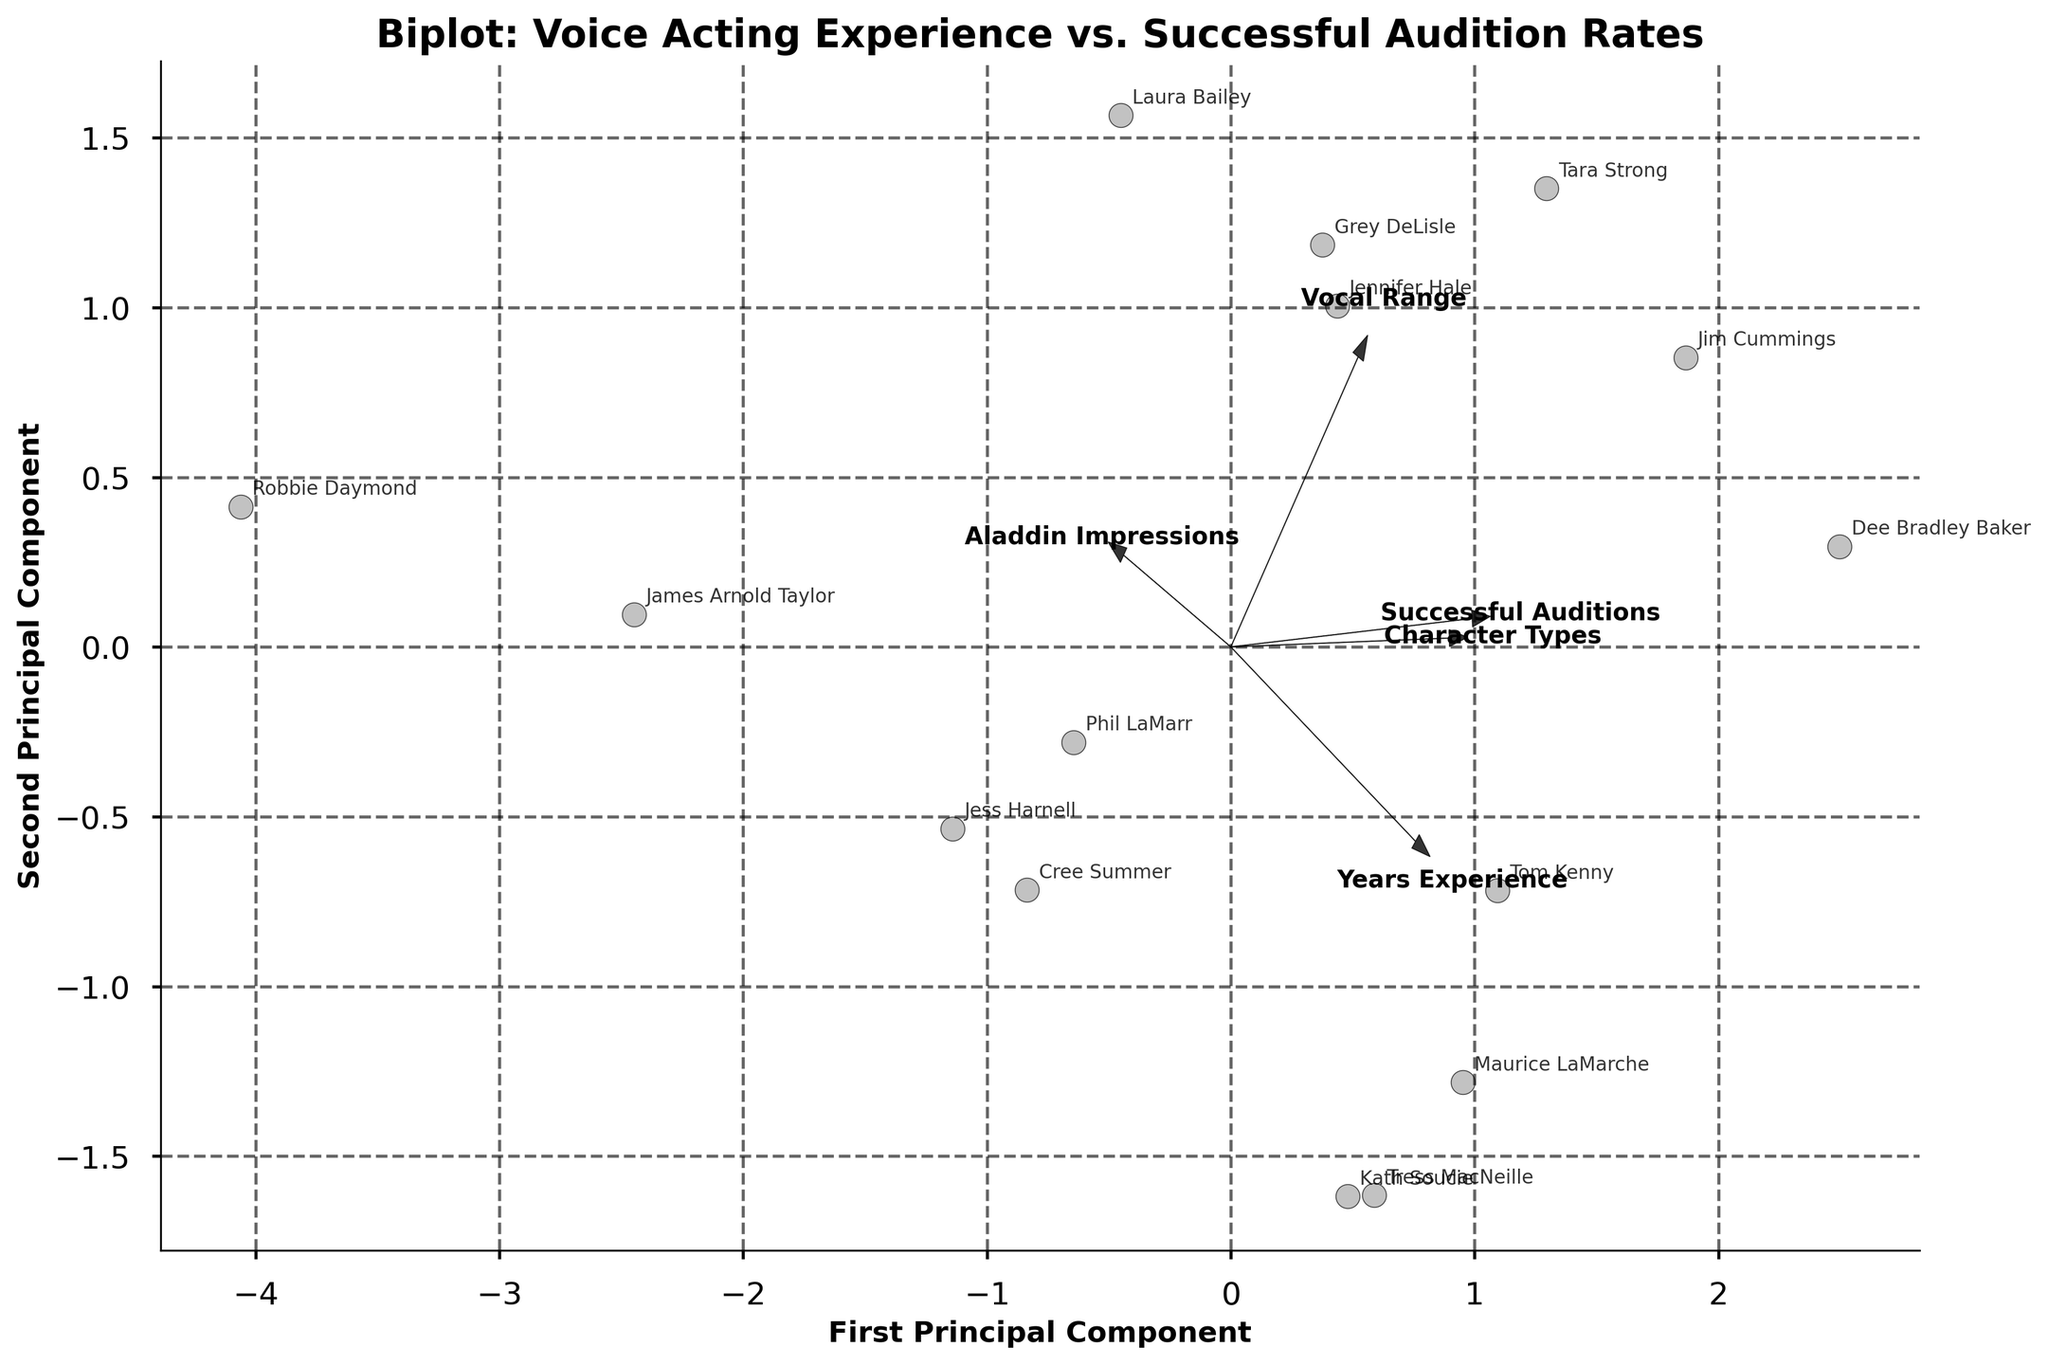What does the title of the plot say? The title is positioned at the top of the plot. It reads, "Biplot: Voice Acting Experience vs. Successful Audition Rates."
Answer: Biplot: Voice Acting Experience vs. Successful Audition Rates How many arrows are shown in the plot, and what do they represent? There are five arrows, representing the features 'Years Experience', 'Successful Auditions', 'Vocal Range', 'Character Types', and 'Aladdin Impressions'. These arrows indicate the direction and magnitude of each feature’s contribution to the principal components.
Answer: Five arrows Which voice actor appears furthest in the positive direction of the second principal component? By examining the y-axis, which represents the second principal component, we can see which data point is furthest in the positive direction. Tara Strong's name appears furthest up on this axis.
Answer: Tara Strong Are 'Successful Auditions' and 'Character Types' positively correlated according to the biplot? To determine the correlation, observe whether the arrows for 'Successful Auditions' and 'Character Types' point in the same general direction. Both arrows are pointing towards the same quadrant indicating a positive correlation.
Answer: Yes Can you identify any groups or clusters of voice actors in the biplot? Look for clusters of data points in the figure that are close to each other. For example, Tom Kenny, Cree Summer, and Grey DeLisle are clustered closely, suggesting they have similar profiles according to the principal components.
Answer: Tom Kenny, Cree Summer, Grey DeLisle Which feature seems to align most closely with the first principal component? The first principal component is represented by the x-axis. By observing which arrow aligns most closely with this axis, we can infer that 'Years Experience' is the feature most aligned with the first principal component.
Answer: Years Experience How does 'Aladdin Impressions' contribute to the second principal component? The 'Aladdin Impressions' arrow should be examined in relation to the second principal component, which is the y-axis. The arrow is seen pointing upwards, indicating a positive contribution to the second principal component.
Answer: Positively Which voice actor is represented by the point closest to the arrow representing 'Years Experience'? To find this, look for the data point that is nearest to the direction of the 'Years Experience' arrow. The point closest to this arrow represents Jim Cummings.
Answer: Jim Cummings Is there a voice actor whose position suggests they have balanced high values across all five features? A balanced high value would place a voice actor near the origin where arrows converge, however, points that are further away suggest strong feature influence. No voice actor is perfectly at the origin, but James Arnold Taylor and Jim Cummings are relatively balanced in terms of position.
Answer: James Arnold Taylor and Jim Cummings Which two features appear to be least correlated, based on the biplot? To find the least correlated features, look for arrows that point in very different directions or are nearly perpendicular. 'Aladdin Impressions' and 'Character Types' point in very different directions, indicating a lower correlation between these two features.
Answer: Aladdin Impressions and Character Types 